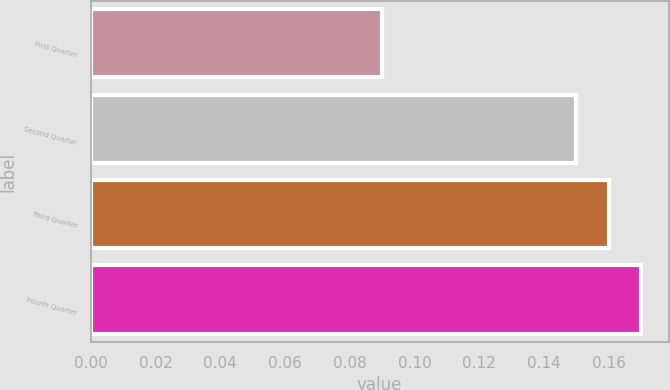Convert chart to OTSL. <chart><loc_0><loc_0><loc_500><loc_500><bar_chart><fcel>First Quarter<fcel>Second Quarter<fcel>Third Quarter<fcel>Fourth Quarter<nl><fcel>0.09<fcel>0.15<fcel>0.16<fcel>0.17<nl></chart> 